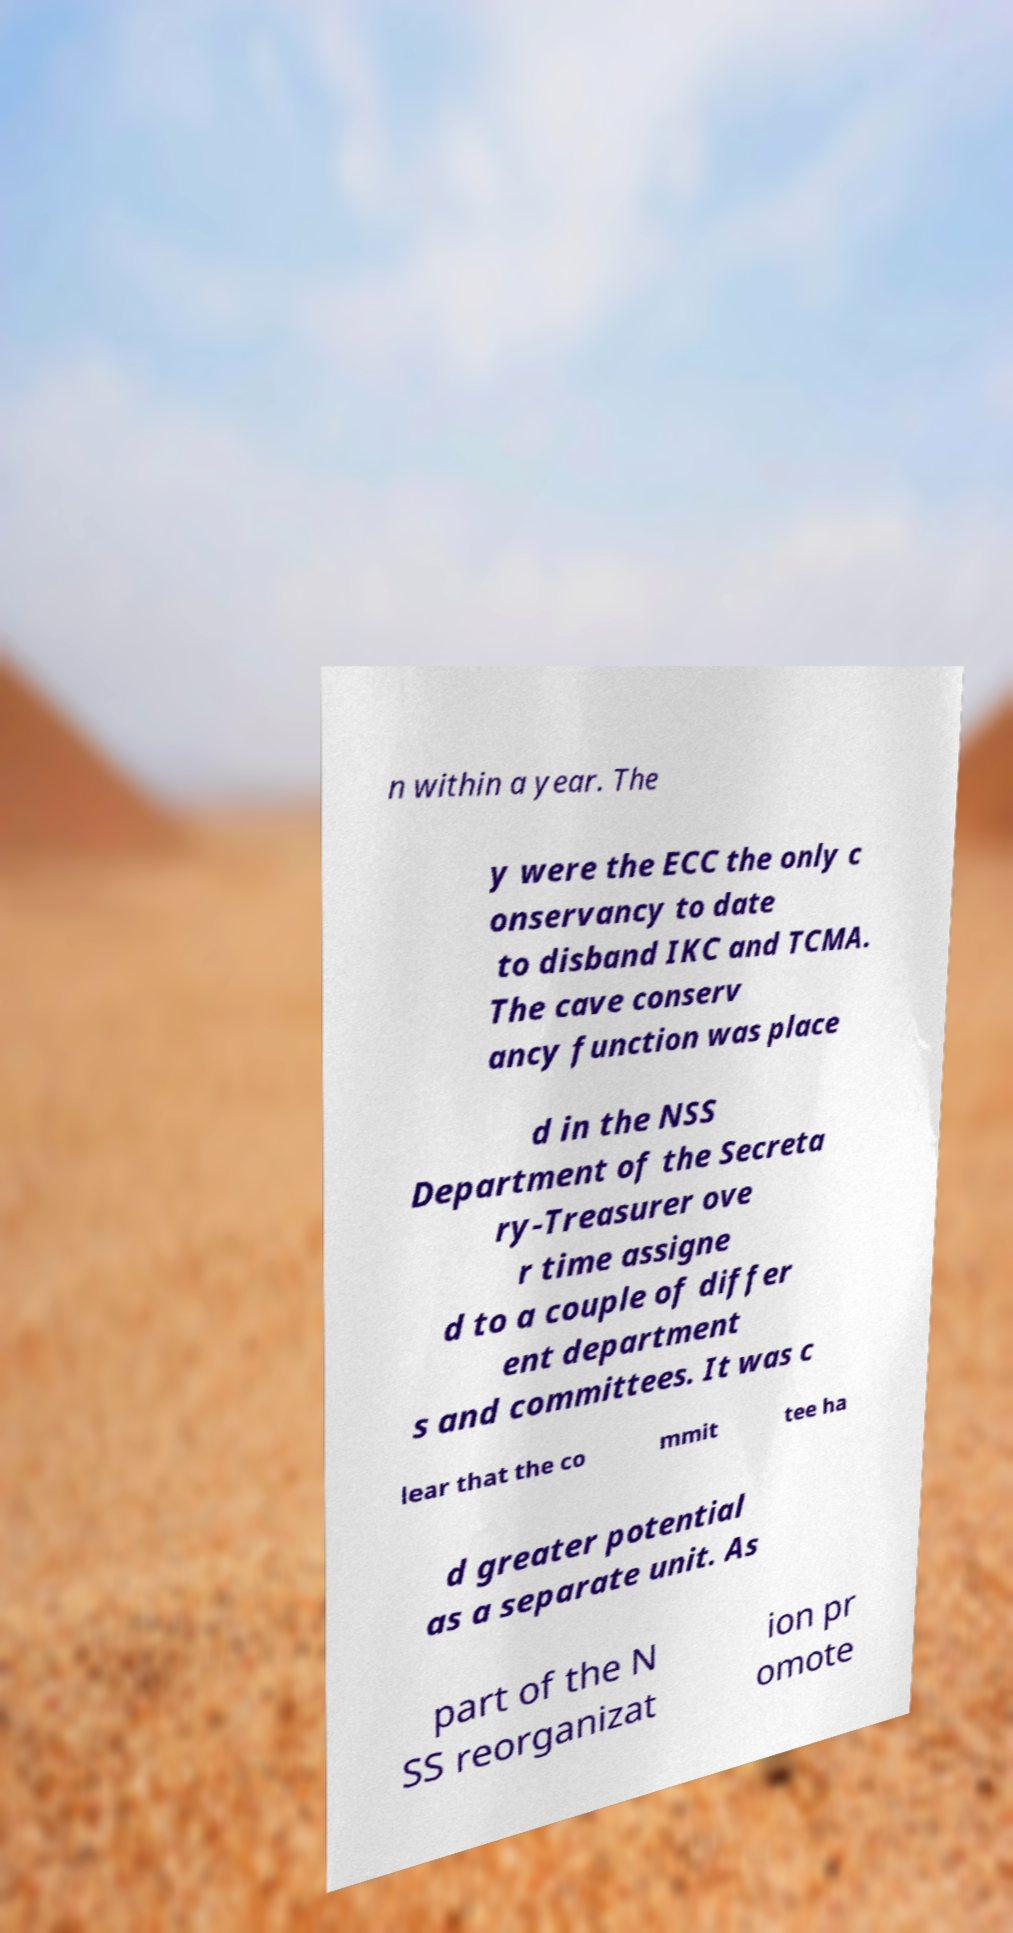Could you extract and type out the text from this image? n within a year. The y were the ECC the only c onservancy to date to disband IKC and TCMA. The cave conserv ancy function was place d in the NSS Department of the Secreta ry-Treasurer ove r time assigne d to a couple of differ ent department s and committees. It was c lear that the co mmit tee ha d greater potential as a separate unit. As part of the N SS reorganizat ion pr omote 